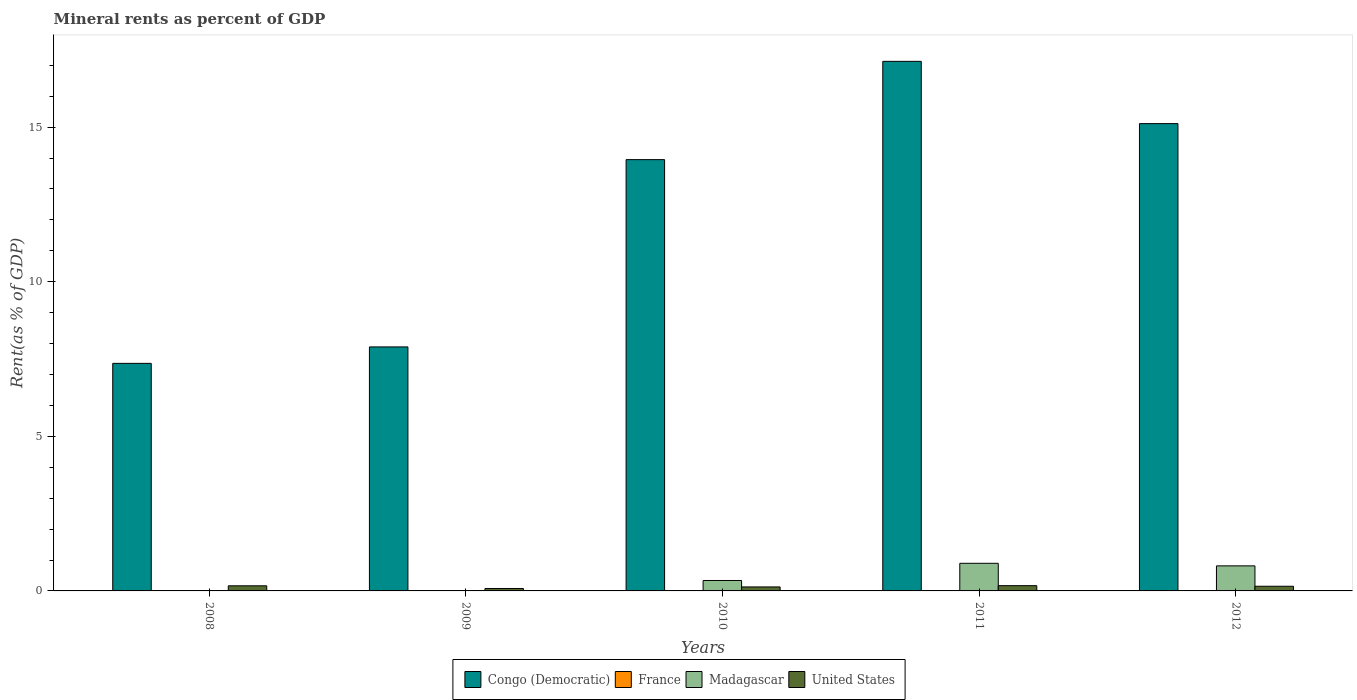How many bars are there on the 4th tick from the right?
Offer a very short reply. 4. What is the label of the 2nd group of bars from the left?
Your response must be concise. 2009. In how many cases, is the number of bars for a given year not equal to the number of legend labels?
Offer a terse response. 0. What is the mineral rent in Madagascar in 2010?
Provide a succinct answer. 0.34. Across all years, what is the maximum mineral rent in Madagascar?
Provide a succinct answer. 0.89. Across all years, what is the minimum mineral rent in Madagascar?
Provide a short and direct response. 0.01. What is the total mineral rent in Madagascar in the graph?
Offer a terse response. 2.06. What is the difference between the mineral rent in Congo (Democratic) in 2008 and that in 2012?
Provide a short and direct response. -7.75. What is the difference between the mineral rent in United States in 2008 and the mineral rent in Madagascar in 2010?
Your response must be concise. -0.17. What is the average mineral rent in Congo (Democratic) per year?
Keep it short and to the point. 12.29. In the year 2008, what is the difference between the mineral rent in United States and mineral rent in France?
Make the answer very short. 0.16. In how many years, is the mineral rent in United States greater than 5 %?
Your answer should be compact. 0. What is the ratio of the mineral rent in Madagascar in 2010 to that in 2012?
Offer a terse response. 0.42. Is the difference between the mineral rent in United States in 2010 and 2012 greater than the difference between the mineral rent in France in 2010 and 2012?
Your response must be concise. No. What is the difference between the highest and the second highest mineral rent in France?
Provide a short and direct response. 0. What is the difference between the highest and the lowest mineral rent in United States?
Your answer should be compact. 0.09. Is it the case that in every year, the sum of the mineral rent in Congo (Democratic) and mineral rent in France is greater than the sum of mineral rent in Madagascar and mineral rent in United States?
Your answer should be compact. Yes. What does the 4th bar from the left in 2011 represents?
Ensure brevity in your answer.  United States. How many bars are there?
Ensure brevity in your answer.  20. What is the difference between two consecutive major ticks on the Y-axis?
Provide a short and direct response. 5. Does the graph contain any zero values?
Make the answer very short. No. Where does the legend appear in the graph?
Your answer should be compact. Bottom center. How are the legend labels stacked?
Offer a very short reply. Horizontal. What is the title of the graph?
Keep it short and to the point. Mineral rents as percent of GDP. Does "Kazakhstan" appear as one of the legend labels in the graph?
Your response must be concise. No. What is the label or title of the Y-axis?
Make the answer very short. Rent(as % of GDP). What is the Rent(as % of GDP) in Congo (Democratic) in 2008?
Your answer should be very brief. 7.36. What is the Rent(as % of GDP) of France in 2008?
Give a very brief answer. 0. What is the Rent(as % of GDP) of Madagascar in 2008?
Offer a very short reply. 0.01. What is the Rent(as % of GDP) in United States in 2008?
Provide a succinct answer. 0.17. What is the Rent(as % of GDP) of Congo (Democratic) in 2009?
Ensure brevity in your answer.  7.89. What is the Rent(as % of GDP) of France in 2009?
Give a very brief answer. 0. What is the Rent(as % of GDP) of Madagascar in 2009?
Provide a succinct answer. 0.01. What is the Rent(as % of GDP) in United States in 2009?
Provide a succinct answer. 0.08. What is the Rent(as % of GDP) of Congo (Democratic) in 2010?
Give a very brief answer. 13.95. What is the Rent(as % of GDP) in France in 2010?
Give a very brief answer. 0. What is the Rent(as % of GDP) of Madagascar in 2010?
Ensure brevity in your answer.  0.34. What is the Rent(as % of GDP) in United States in 2010?
Offer a very short reply. 0.13. What is the Rent(as % of GDP) in Congo (Democratic) in 2011?
Your answer should be compact. 17.13. What is the Rent(as % of GDP) of France in 2011?
Make the answer very short. 0. What is the Rent(as % of GDP) in Madagascar in 2011?
Your answer should be compact. 0.89. What is the Rent(as % of GDP) in United States in 2011?
Ensure brevity in your answer.  0.17. What is the Rent(as % of GDP) of Congo (Democratic) in 2012?
Ensure brevity in your answer.  15.11. What is the Rent(as % of GDP) of France in 2012?
Your response must be concise. 0. What is the Rent(as % of GDP) of Madagascar in 2012?
Offer a terse response. 0.81. What is the Rent(as % of GDP) in United States in 2012?
Keep it short and to the point. 0.15. Across all years, what is the maximum Rent(as % of GDP) of Congo (Democratic)?
Offer a very short reply. 17.13. Across all years, what is the maximum Rent(as % of GDP) of France?
Your response must be concise. 0. Across all years, what is the maximum Rent(as % of GDP) in Madagascar?
Give a very brief answer. 0.89. Across all years, what is the maximum Rent(as % of GDP) of United States?
Offer a terse response. 0.17. Across all years, what is the minimum Rent(as % of GDP) of Congo (Democratic)?
Your answer should be compact. 7.36. Across all years, what is the minimum Rent(as % of GDP) in France?
Keep it short and to the point. 0. Across all years, what is the minimum Rent(as % of GDP) of Madagascar?
Provide a short and direct response. 0.01. Across all years, what is the minimum Rent(as % of GDP) in United States?
Your answer should be compact. 0.08. What is the total Rent(as % of GDP) of Congo (Democratic) in the graph?
Your answer should be very brief. 61.44. What is the total Rent(as % of GDP) of France in the graph?
Your response must be concise. 0.01. What is the total Rent(as % of GDP) of Madagascar in the graph?
Offer a very short reply. 2.06. What is the total Rent(as % of GDP) in United States in the graph?
Offer a terse response. 0.69. What is the difference between the Rent(as % of GDP) of Congo (Democratic) in 2008 and that in 2009?
Offer a terse response. -0.53. What is the difference between the Rent(as % of GDP) of France in 2008 and that in 2009?
Keep it short and to the point. 0. What is the difference between the Rent(as % of GDP) of Madagascar in 2008 and that in 2009?
Provide a succinct answer. 0. What is the difference between the Rent(as % of GDP) in United States in 2008 and that in 2009?
Your answer should be compact. 0.09. What is the difference between the Rent(as % of GDP) of Congo (Democratic) in 2008 and that in 2010?
Keep it short and to the point. -6.59. What is the difference between the Rent(as % of GDP) in France in 2008 and that in 2010?
Give a very brief answer. -0. What is the difference between the Rent(as % of GDP) of Madagascar in 2008 and that in 2010?
Provide a succinct answer. -0.33. What is the difference between the Rent(as % of GDP) of United States in 2008 and that in 2010?
Your answer should be compact. 0.04. What is the difference between the Rent(as % of GDP) in Congo (Democratic) in 2008 and that in 2011?
Provide a short and direct response. -9.77. What is the difference between the Rent(as % of GDP) in France in 2008 and that in 2011?
Offer a very short reply. -0. What is the difference between the Rent(as % of GDP) of Madagascar in 2008 and that in 2011?
Provide a short and direct response. -0.88. What is the difference between the Rent(as % of GDP) in United States in 2008 and that in 2011?
Give a very brief answer. -0. What is the difference between the Rent(as % of GDP) in Congo (Democratic) in 2008 and that in 2012?
Offer a terse response. -7.75. What is the difference between the Rent(as % of GDP) in France in 2008 and that in 2012?
Make the answer very short. -0. What is the difference between the Rent(as % of GDP) in Madagascar in 2008 and that in 2012?
Make the answer very short. -0.8. What is the difference between the Rent(as % of GDP) of United States in 2008 and that in 2012?
Your response must be concise. 0.01. What is the difference between the Rent(as % of GDP) in Congo (Democratic) in 2009 and that in 2010?
Make the answer very short. -6.06. What is the difference between the Rent(as % of GDP) of France in 2009 and that in 2010?
Give a very brief answer. -0. What is the difference between the Rent(as % of GDP) in Madagascar in 2009 and that in 2010?
Keep it short and to the point. -0.33. What is the difference between the Rent(as % of GDP) of United States in 2009 and that in 2010?
Provide a succinct answer. -0.05. What is the difference between the Rent(as % of GDP) in Congo (Democratic) in 2009 and that in 2011?
Ensure brevity in your answer.  -9.24. What is the difference between the Rent(as % of GDP) in France in 2009 and that in 2011?
Provide a short and direct response. -0. What is the difference between the Rent(as % of GDP) of Madagascar in 2009 and that in 2011?
Offer a terse response. -0.89. What is the difference between the Rent(as % of GDP) of United States in 2009 and that in 2011?
Your answer should be very brief. -0.09. What is the difference between the Rent(as % of GDP) of Congo (Democratic) in 2009 and that in 2012?
Your answer should be compact. -7.22. What is the difference between the Rent(as % of GDP) of France in 2009 and that in 2012?
Your answer should be very brief. -0. What is the difference between the Rent(as % of GDP) of Madagascar in 2009 and that in 2012?
Your answer should be compact. -0.8. What is the difference between the Rent(as % of GDP) in United States in 2009 and that in 2012?
Provide a short and direct response. -0.07. What is the difference between the Rent(as % of GDP) of Congo (Democratic) in 2010 and that in 2011?
Offer a very short reply. -3.18. What is the difference between the Rent(as % of GDP) in France in 2010 and that in 2011?
Keep it short and to the point. -0. What is the difference between the Rent(as % of GDP) of Madagascar in 2010 and that in 2011?
Ensure brevity in your answer.  -0.56. What is the difference between the Rent(as % of GDP) of United States in 2010 and that in 2011?
Your answer should be very brief. -0.04. What is the difference between the Rent(as % of GDP) in Congo (Democratic) in 2010 and that in 2012?
Offer a very short reply. -1.16. What is the difference between the Rent(as % of GDP) of France in 2010 and that in 2012?
Ensure brevity in your answer.  -0. What is the difference between the Rent(as % of GDP) in Madagascar in 2010 and that in 2012?
Your answer should be compact. -0.47. What is the difference between the Rent(as % of GDP) of United States in 2010 and that in 2012?
Ensure brevity in your answer.  -0.02. What is the difference between the Rent(as % of GDP) of Congo (Democratic) in 2011 and that in 2012?
Offer a very short reply. 2.01. What is the difference between the Rent(as % of GDP) of France in 2011 and that in 2012?
Ensure brevity in your answer.  -0. What is the difference between the Rent(as % of GDP) in Madagascar in 2011 and that in 2012?
Ensure brevity in your answer.  0.08. What is the difference between the Rent(as % of GDP) in United States in 2011 and that in 2012?
Ensure brevity in your answer.  0.02. What is the difference between the Rent(as % of GDP) in Congo (Democratic) in 2008 and the Rent(as % of GDP) in France in 2009?
Ensure brevity in your answer.  7.36. What is the difference between the Rent(as % of GDP) in Congo (Democratic) in 2008 and the Rent(as % of GDP) in Madagascar in 2009?
Offer a very short reply. 7.35. What is the difference between the Rent(as % of GDP) of Congo (Democratic) in 2008 and the Rent(as % of GDP) of United States in 2009?
Your answer should be very brief. 7.28. What is the difference between the Rent(as % of GDP) in France in 2008 and the Rent(as % of GDP) in Madagascar in 2009?
Provide a short and direct response. -0.01. What is the difference between the Rent(as % of GDP) in France in 2008 and the Rent(as % of GDP) in United States in 2009?
Give a very brief answer. -0.08. What is the difference between the Rent(as % of GDP) of Madagascar in 2008 and the Rent(as % of GDP) of United States in 2009?
Ensure brevity in your answer.  -0.07. What is the difference between the Rent(as % of GDP) of Congo (Democratic) in 2008 and the Rent(as % of GDP) of France in 2010?
Your answer should be very brief. 7.36. What is the difference between the Rent(as % of GDP) of Congo (Democratic) in 2008 and the Rent(as % of GDP) of Madagascar in 2010?
Offer a very short reply. 7.02. What is the difference between the Rent(as % of GDP) in Congo (Democratic) in 2008 and the Rent(as % of GDP) in United States in 2010?
Keep it short and to the point. 7.23. What is the difference between the Rent(as % of GDP) of France in 2008 and the Rent(as % of GDP) of Madagascar in 2010?
Keep it short and to the point. -0.34. What is the difference between the Rent(as % of GDP) of France in 2008 and the Rent(as % of GDP) of United States in 2010?
Give a very brief answer. -0.13. What is the difference between the Rent(as % of GDP) of Madagascar in 2008 and the Rent(as % of GDP) of United States in 2010?
Offer a terse response. -0.12. What is the difference between the Rent(as % of GDP) in Congo (Democratic) in 2008 and the Rent(as % of GDP) in France in 2011?
Give a very brief answer. 7.36. What is the difference between the Rent(as % of GDP) of Congo (Democratic) in 2008 and the Rent(as % of GDP) of Madagascar in 2011?
Offer a very short reply. 6.47. What is the difference between the Rent(as % of GDP) in Congo (Democratic) in 2008 and the Rent(as % of GDP) in United States in 2011?
Provide a short and direct response. 7.19. What is the difference between the Rent(as % of GDP) in France in 2008 and the Rent(as % of GDP) in Madagascar in 2011?
Your answer should be compact. -0.89. What is the difference between the Rent(as % of GDP) of France in 2008 and the Rent(as % of GDP) of United States in 2011?
Your response must be concise. -0.17. What is the difference between the Rent(as % of GDP) in Madagascar in 2008 and the Rent(as % of GDP) in United States in 2011?
Offer a terse response. -0.16. What is the difference between the Rent(as % of GDP) of Congo (Democratic) in 2008 and the Rent(as % of GDP) of France in 2012?
Ensure brevity in your answer.  7.36. What is the difference between the Rent(as % of GDP) in Congo (Democratic) in 2008 and the Rent(as % of GDP) in Madagascar in 2012?
Provide a succinct answer. 6.55. What is the difference between the Rent(as % of GDP) of Congo (Democratic) in 2008 and the Rent(as % of GDP) of United States in 2012?
Your answer should be compact. 7.21. What is the difference between the Rent(as % of GDP) in France in 2008 and the Rent(as % of GDP) in Madagascar in 2012?
Offer a very short reply. -0.81. What is the difference between the Rent(as % of GDP) in France in 2008 and the Rent(as % of GDP) in United States in 2012?
Your answer should be very brief. -0.15. What is the difference between the Rent(as % of GDP) of Madagascar in 2008 and the Rent(as % of GDP) of United States in 2012?
Give a very brief answer. -0.14. What is the difference between the Rent(as % of GDP) in Congo (Democratic) in 2009 and the Rent(as % of GDP) in France in 2010?
Keep it short and to the point. 7.89. What is the difference between the Rent(as % of GDP) in Congo (Democratic) in 2009 and the Rent(as % of GDP) in Madagascar in 2010?
Your answer should be compact. 7.55. What is the difference between the Rent(as % of GDP) of Congo (Democratic) in 2009 and the Rent(as % of GDP) of United States in 2010?
Give a very brief answer. 7.76. What is the difference between the Rent(as % of GDP) in France in 2009 and the Rent(as % of GDP) in Madagascar in 2010?
Ensure brevity in your answer.  -0.34. What is the difference between the Rent(as % of GDP) in France in 2009 and the Rent(as % of GDP) in United States in 2010?
Your answer should be compact. -0.13. What is the difference between the Rent(as % of GDP) in Madagascar in 2009 and the Rent(as % of GDP) in United States in 2010?
Provide a succinct answer. -0.12. What is the difference between the Rent(as % of GDP) in Congo (Democratic) in 2009 and the Rent(as % of GDP) in France in 2011?
Your answer should be compact. 7.89. What is the difference between the Rent(as % of GDP) in Congo (Democratic) in 2009 and the Rent(as % of GDP) in Madagascar in 2011?
Your answer should be compact. 7. What is the difference between the Rent(as % of GDP) of Congo (Democratic) in 2009 and the Rent(as % of GDP) of United States in 2011?
Provide a short and direct response. 7.72. What is the difference between the Rent(as % of GDP) in France in 2009 and the Rent(as % of GDP) in Madagascar in 2011?
Make the answer very short. -0.89. What is the difference between the Rent(as % of GDP) of France in 2009 and the Rent(as % of GDP) of United States in 2011?
Make the answer very short. -0.17. What is the difference between the Rent(as % of GDP) of Madagascar in 2009 and the Rent(as % of GDP) of United States in 2011?
Offer a very short reply. -0.16. What is the difference between the Rent(as % of GDP) in Congo (Democratic) in 2009 and the Rent(as % of GDP) in France in 2012?
Offer a terse response. 7.89. What is the difference between the Rent(as % of GDP) of Congo (Democratic) in 2009 and the Rent(as % of GDP) of Madagascar in 2012?
Your answer should be compact. 7.08. What is the difference between the Rent(as % of GDP) of Congo (Democratic) in 2009 and the Rent(as % of GDP) of United States in 2012?
Provide a short and direct response. 7.74. What is the difference between the Rent(as % of GDP) of France in 2009 and the Rent(as % of GDP) of Madagascar in 2012?
Your response must be concise. -0.81. What is the difference between the Rent(as % of GDP) in France in 2009 and the Rent(as % of GDP) in United States in 2012?
Offer a very short reply. -0.15. What is the difference between the Rent(as % of GDP) of Madagascar in 2009 and the Rent(as % of GDP) of United States in 2012?
Offer a very short reply. -0.14. What is the difference between the Rent(as % of GDP) of Congo (Democratic) in 2010 and the Rent(as % of GDP) of France in 2011?
Your answer should be very brief. 13.95. What is the difference between the Rent(as % of GDP) of Congo (Democratic) in 2010 and the Rent(as % of GDP) of Madagascar in 2011?
Your response must be concise. 13.06. What is the difference between the Rent(as % of GDP) of Congo (Democratic) in 2010 and the Rent(as % of GDP) of United States in 2011?
Offer a terse response. 13.78. What is the difference between the Rent(as % of GDP) of France in 2010 and the Rent(as % of GDP) of Madagascar in 2011?
Keep it short and to the point. -0.89. What is the difference between the Rent(as % of GDP) in France in 2010 and the Rent(as % of GDP) in United States in 2011?
Keep it short and to the point. -0.17. What is the difference between the Rent(as % of GDP) of Madagascar in 2010 and the Rent(as % of GDP) of United States in 2011?
Your response must be concise. 0.17. What is the difference between the Rent(as % of GDP) in Congo (Democratic) in 2010 and the Rent(as % of GDP) in France in 2012?
Offer a terse response. 13.95. What is the difference between the Rent(as % of GDP) of Congo (Democratic) in 2010 and the Rent(as % of GDP) of Madagascar in 2012?
Your answer should be very brief. 13.14. What is the difference between the Rent(as % of GDP) of Congo (Democratic) in 2010 and the Rent(as % of GDP) of United States in 2012?
Give a very brief answer. 13.8. What is the difference between the Rent(as % of GDP) in France in 2010 and the Rent(as % of GDP) in Madagascar in 2012?
Keep it short and to the point. -0.81. What is the difference between the Rent(as % of GDP) in France in 2010 and the Rent(as % of GDP) in United States in 2012?
Ensure brevity in your answer.  -0.15. What is the difference between the Rent(as % of GDP) of Madagascar in 2010 and the Rent(as % of GDP) of United States in 2012?
Offer a very short reply. 0.19. What is the difference between the Rent(as % of GDP) of Congo (Democratic) in 2011 and the Rent(as % of GDP) of France in 2012?
Your answer should be very brief. 17.12. What is the difference between the Rent(as % of GDP) in Congo (Democratic) in 2011 and the Rent(as % of GDP) in Madagascar in 2012?
Your answer should be very brief. 16.32. What is the difference between the Rent(as % of GDP) in Congo (Democratic) in 2011 and the Rent(as % of GDP) in United States in 2012?
Offer a terse response. 16.98. What is the difference between the Rent(as % of GDP) in France in 2011 and the Rent(as % of GDP) in Madagascar in 2012?
Make the answer very short. -0.81. What is the difference between the Rent(as % of GDP) in France in 2011 and the Rent(as % of GDP) in United States in 2012?
Offer a terse response. -0.15. What is the difference between the Rent(as % of GDP) of Madagascar in 2011 and the Rent(as % of GDP) of United States in 2012?
Your answer should be very brief. 0.74. What is the average Rent(as % of GDP) in Congo (Democratic) per year?
Provide a short and direct response. 12.29. What is the average Rent(as % of GDP) of France per year?
Offer a very short reply. 0. What is the average Rent(as % of GDP) in Madagascar per year?
Your response must be concise. 0.41. What is the average Rent(as % of GDP) in United States per year?
Provide a succinct answer. 0.14. In the year 2008, what is the difference between the Rent(as % of GDP) of Congo (Democratic) and Rent(as % of GDP) of France?
Provide a succinct answer. 7.36. In the year 2008, what is the difference between the Rent(as % of GDP) of Congo (Democratic) and Rent(as % of GDP) of Madagascar?
Your response must be concise. 7.35. In the year 2008, what is the difference between the Rent(as % of GDP) of Congo (Democratic) and Rent(as % of GDP) of United States?
Ensure brevity in your answer.  7.19. In the year 2008, what is the difference between the Rent(as % of GDP) of France and Rent(as % of GDP) of Madagascar?
Ensure brevity in your answer.  -0.01. In the year 2008, what is the difference between the Rent(as % of GDP) of France and Rent(as % of GDP) of United States?
Offer a very short reply. -0.16. In the year 2008, what is the difference between the Rent(as % of GDP) of Madagascar and Rent(as % of GDP) of United States?
Offer a very short reply. -0.16. In the year 2009, what is the difference between the Rent(as % of GDP) of Congo (Democratic) and Rent(as % of GDP) of France?
Provide a short and direct response. 7.89. In the year 2009, what is the difference between the Rent(as % of GDP) in Congo (Democratic) and Rent(as % of GDP) in Madagascar?
Make the answer very short. 7.88. In the year 2009, what is the difference between the Rent(as % of GDP) in Congo (Democratic) and Rent(as % of GDP) in United States?
Make the answer very short. 7.81. In the year 2009, what is the difference between the Rent(as % of GDP) in France and Rent(as % of GDP) in Madagascar?
Give a very brief answer. -0.01. In the year 2009, what is the difference between the Rent(as % of GDP) in France and Rent(as % of GDP) in United States?
Give a very brief answer. -0.08. In the year 2009, what is the difference between the Rent(as % of GDP) of Madagascar and Rent(as % of GDP) of United States?
Your answer should be very brief. -0.07. In the year 2010, what is the difference between the Rent(as % of GDP) in Congo (Democratic) and Rent(as % of GDP) in France?
Provide a short and direct response. 13.95. In the year 2010, what is the difference between the Rent(as % of GDP) of Congo (Democratic) and Rent(as % of GDP) of Madagascar?
Keep it short and to the point. 13.61. In the year 2010, what is the difference between the Rent(as % of GDP) in Congo (Democratic) and Rent(as % of GDP) in United States?
Your answer should be very brief. 13.82. In the year 2010, what is the difference between the Rent(as % of GDP) of France and Rent(as % of GDP) of Madagascar?
Offer a terse response. -0.34. In the year 2010, what is the difference between the Rent(as % of GDP) of France and Rent(as % of GDP) of United States?
Provide a succinct answer. -0.13. In the year 2010, what is the difference between the Rent(as % of GDP) of Madagascar and Rent(as % of GDP) of United States?
Give a very brief answer. 0.21. In the year 2011, what is the difference between the Rent(as % of GDP) in Congo (Democratic) and Rent(as % of GDP) in France?
Your answer should be compact. 17.12. In the year 2011, what is the difference between the Rent(as % of GDP) in Congo (Democratic) and Rent(as % of GDP) in Madagascar?
Make the answer very short. 16.23. In the year 2011, what is the difference between the Rent(as % of GDP) in Congo (Democratic) and Rent(as % of GDP) in United States?
Offer a terse response. 16.96. In the year 2011, what is the difference between the Rent(as % of GDP) of France and Rent(as % of GDP) of Madagascar?
Offer a terse response. -0.89. In the year 2011, what is the difference between the Rent(as % of GDP) in France and Rent(as % of GDP) in United States?
Your response must be concise. -0.17. In the year 2011, what is the difference between the Rent(as % of GDP) in Madagascar and Rent(as % of GDP) in United States?
Your answer should be compact. 0.72. In the year 2012, what is the difference between the Rent(as % of GDP) of Congo (Democratic) and Rent(as % of GDP) of France?
Make the answer very short. 15.11. In the year 2012, what is the difference between the Rent(as % of GDP) of Congo (Democratic) and Rent(as % of GDP) of Madagascar?
Your answer should be very brief. 14.3. In the year 2012, what is the difference between the Rent(as % of GDP) of Congo (Democratic) and Rent(as % of GDP) of United States?
Give a very brief answer. 14.96. In the year 2012, what is the difference between the Rent(as % of GDP) in France and Rent(as % of GDP) in Madagascar?
Keep it short and to the point. -0.81. In the year 2012, what is the difference between the Rent(as % of GDP) in France and Rent(as % of GDP) in United States?
Offer a terse response. -0.15. In the year 2012, what is the difference between the Rent(as % of GDP) of Madagascar and Rent(as % of GDP) of United States?
Your response must be concise. 0.66. What is the ratio of the Rent(as % of GDP) of Congo (Democratic) in 2008 to that in 2009?
Give a very brief answer. 0.93. What is the ratio of the Rent(as % of GDP) of France in 2008 to that in 2009?
Your response must be concise. 1.06. What is the ratio of the Rent(as % of GDP) in Madagascar in 2008 to that in 2009?
Provide a succinct answer. 1.16. What is the ratio of the Rent(as % of GDP) in United States in 2008 to that in 2009?
Your response must be concise. 2.11. What is the ratio of the Rent(as % of GDP) in Congo (Democratic) in 2008 to that in 2010?
Provide a succinct answer. 0.53. What is the ratio of the Rent(as % of GDP) of France in 2008 to that in 2010?
Offer a terse response. 0.77. What is the ratio of the Rent(as % of GDP) in Madagascar in 2008 to that in 2010?
Ensure brevity in your answer.  0.02. What is the ratio of the Rent(as % of GDP) in United States in 2008 to that in 2010?
Keep it short and to the point. 1.28. What is the ratio of the Rent(as % of GDP) in Congo (Democratic) in 2008 to that in 2011?
Give a very brief answer. 0.43. What is the ratio of the Rent(as % of GDP) in France in 2008 to that in 2011?
Provide a succinct answer. 0.59. What is the ratio of the Rent(as % of GDP) in Madagascar in 2008 to that in 2011?
Your response must be concise. 0.01. What is the ratio of the Rent(as % of GDP) in Congo (Democratic) in 2008 to that in 2012?
Make the answer very short. 0.49. What is the ratio of the Rent(as % of GDP) of France in 2008 to that in 2012?
Offer a terse response. 0.51. What is the ratio of the Rent(as % of GDP) of Madagascar in 2008 to that in 2012?
Your answer should be very brief. 0.01. What is the ratio of the Rent(as % of GDP) in United States in 2008 to that in 2012?
Offer a very short reply. 1.1. What is the ratio of the Rent(as % of GDP) in Congo (Democratic) in 2009 to that in 2010?
Keep it short and to the point. 0.57. What is the ratio of the Rent(as % of GDP) in France in 2009 to that in 2010?
Give a very brief answer. 0.73. What is the ratio of the Rent(as % of GDP) in Madagascar in 2009 to that in 2010?
Offer a very short reply. 0.02. What is the ratio of the Rent(as % of GDP) of United States in 2009 to that in 2010?
Make the answer very short. 0.61. What is the ratio of the Rent(as % of GDP) of Congo (Democratic) in 2009 to that in 2011?
Give a very brief answer. 0.46. What is the ratio of the Rent(as % of GDP) in France in 2009 to that in 2011?
Your answer should be very brief. 0.56. What is the ratio of the Rent(as % of GDP) of Madagascar in 2009 to that in 2011?
Your answer should be very brief. 0.01. What is the ratio of the Rent(as % of GDP) of United States in 2009 to that in 2011?
Make the answer very short. 0.46. What is the ratio of the Rent(as % of GDP) of Congo (Democratic) in 2009 to that in 2012?
Your answer should be compact. 0.52. What is the ratio of the Rent(as % of GDP) in France in 2009 to that in 2012?
Your answer should be compact. 0.48. What is the ratio of the Rent(as % of GDP) in Madagascar in 2009 to that in 2012?
Keep it short and to the point. 0.01. What is the ratio of the Rent(as % of GDP) in United States in 2009 to that in 2012?
Ensure brevity in your answer.  0.52. What is the ratio of the Rent(as % of GDP) of Congo (Democratic) in 2010 to that in 2011?
Offer a very short reply. 0.81. What is the ratio of the Rent(as % of GDP) in France in 2010 to that in 2011?
Ensure brevity in your answer.  0.77. What is the ratio of the Rent(as % of GDP) in Madagascar in 2010 to that in 2011?
Your answer should be very brief. 0.38. What is the ratio of the Rent(as % of GDP) in United States in 2010 to that in 2011?
Your answer should be very brief. 0.76. What is the ratio of the Rent(as % of GDP) of Congo (Democratic) in 2010 to that in 2012?
Your answer should be compact. 0.92. What is the ratio of the Rent(as % of GDP) of France in 2010 to that in 2012?
Provide a short and direct response. 0.67. What is the ratio of the Rent(as % of GDP) in Madagascar in 2010 to that in 2012?
Offer a very short reply. 0.42. What is the ratio of the Rent(as % of GDP) in United States in 2010 to that in 2012?
Ensure brevity in your answer.  0.86. What is the ratio of the Rent(as % of GDP) of Congo (Democratic) in 2011 to that in 2012?
Your answer should be very brief. 1.13. What is the ratio of the Rent(as % of GDP) of France in 2011 to that in 2012?
Keep it short and to the point. 0.86. What is the ratio of the Rent(as % of GDP) of Madagascar in 2011 to that in 2012?
Give a very brief answer. 1.1. What is the ratio of the Rent(as % of GDP) of United States in 2011 to that in 2012?
Your answer should be compact. 1.13. What is the difference between the highest and the second highest Rent(as % of GDP) in Congo (Democratic)?
Your answer should be compact. 2.01. What is the difference between the highest and the second highest Rent(as % of GDP) in Madagascar?
Your answer should be compact. 0.08. What is the difference between the highest and the second highest Rent(as % of GDP) in United States?
Offer a very short reply. 0. What is the difference between the highest and the lowest Rent(as % of GDP) of Congo (Democratic)?
Ensure brevity in your answer.  9.77. What is the difference between the highest and the lowest Rent(as % of GDP) of France?
Keep it short and to the point. 0. What is the difference between the highest and the lowest Rent(as % of GDP) in Madagascar?
Give a very brief answer. 0.89. What is the difference between the highest and the lowest Rent(as % of GDP) in United States?
Provide a succinct answer. 0.09. 